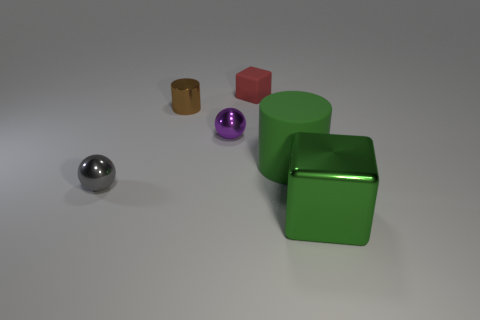There is a small red block behind the small brown shiny cylinder; how many spheres are in front of it?
Provide a short and direct response. 2. Is the number of tiny blocks that are to the left of the red rubber thing less than the number of large matte objects behind the small gray metal thing?
Your answer should be compact. Yes. There is a large object that is in front of the tiny metallic sphere in front of the big rubber cylinder; what is its shape?
Your response must be concise. Cube. What number of other objects are the same material as the tiny gray thing?
Keep it short and to the point. 3. Is the number of small green objects greater than the number of objects?
Make the answer very short. No. What size is the metal sphere behind the green thing that is left of the large object in front of the gray shiny ball?
Offer a very short reply. Small. There is a gray shiny sphere; does it have the same size as the green thing in front of the big green rubber cylinder?
Keep it short and to the point. No. Is the number of tiny metal things on the right side of the gray ball less than the number of big matte cylinders?
Offer a very short reply. No. What number of other blocks have the same color as the large block?
Make the answer very short. 0. Are there fewer rubber objects than green metallic blocks?
Ensure brevity in your answer.  No. 